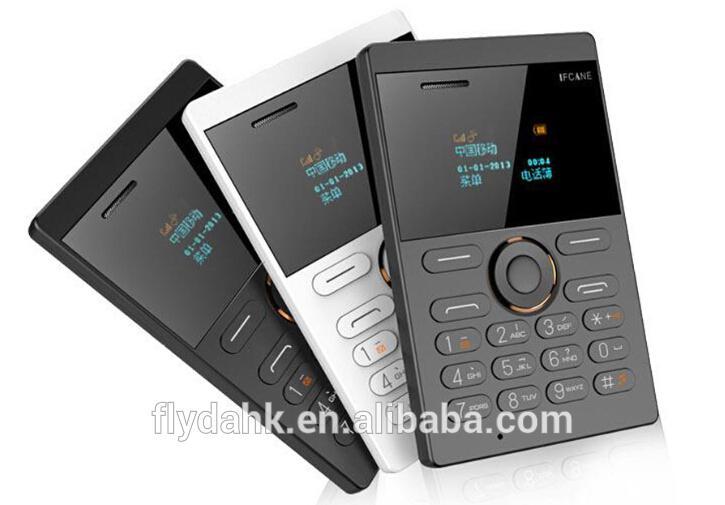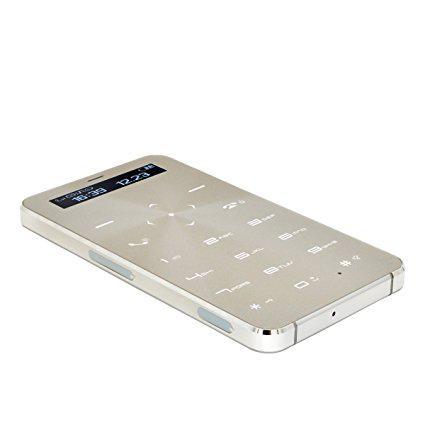The first image is the image on the left, the second image is the image on the right. Evaluate the accuracy of this statement regarding the images: "A person is holding something in the right image.". Is it true? Answer yes or no. No. The first image is the image on the left, the second image is the image on the right. Examine the images to the left and right. Is the description "A person is holding a white device in the image on the left." accurate? Answer yes or no. No. 